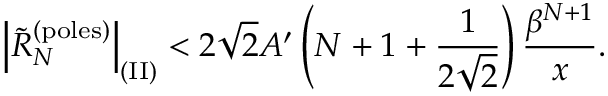Convert formula to latex. <formula><loc_0><loc_0><loc_500><loc_500>\left | \widetilde { R } _ { N } ^ { ( p o l e s ) } \right | _ { ( I I ) } < 2 \sqrt { 2 } A ^ { \prime } \left ( N + 1 + { \frac { 1 } { 2 \sqrt { 2 } } } \right ) { \frac { \beta ^ { N + 1 } } { x } } .</formula> 